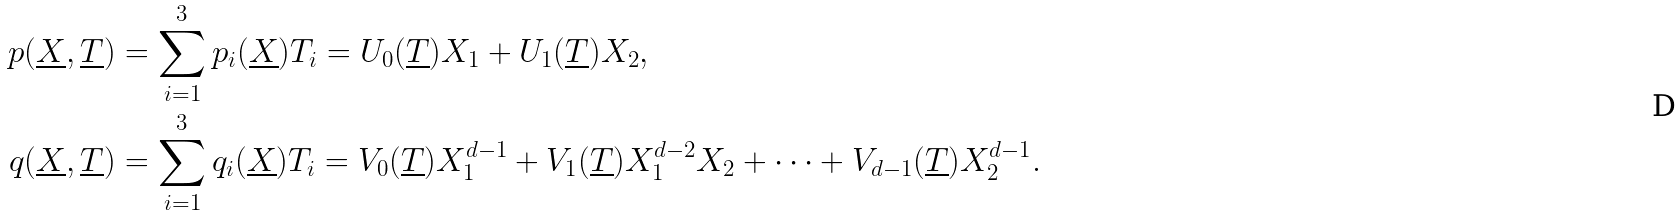<formula> <loc_0><loc_0><loc_500><loc_500>p ( \underline { X } , \underline { T } ) & = \sum _ { i = 1 } ^ { 3 } p _ { i } ( \underline { X } ) T _ { i } = U _ { 0 } ( \underline { T } ) X _ { 1 } + U _ { 1 } ( \underline { T } ) X _ { 2 } , \\ q ( \underline { X } , \underline { T } ) & = \sum _ { i = 1 } ^ { 3 } q _ { i } ( \underline { X } ) T _ { i } = V _ { 0 } ( \underline { T } ) X _ { 1 } ^ { d - 1 } + V _ { 1 } ( \underline { T } ) X _ { 1 } ^ { d - 2 } X _ { 2 } + \cdots + V _ { d - 1 } ( \underline { T } ) X _ { 2 } ^ { d - 1 } .</formula> 